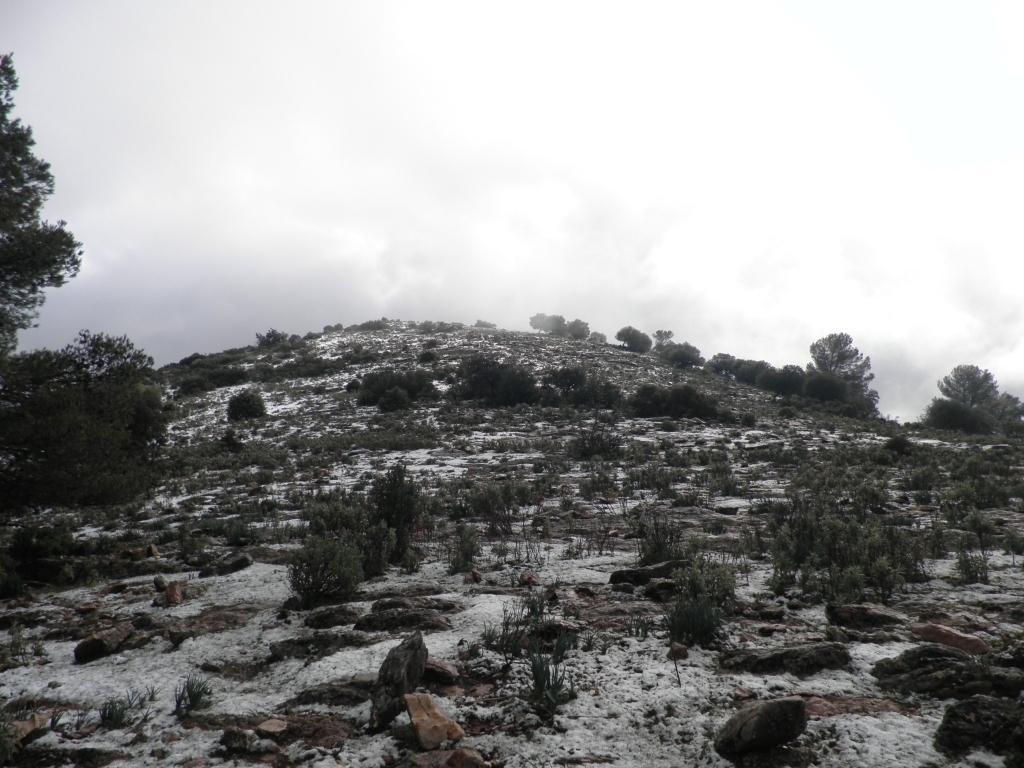Could you give a brief overview of what you see in this image? In this image we can see group of plants and trees on a hill. In the foreground we can see some rocks. In the background we can see the cloudy sky. 